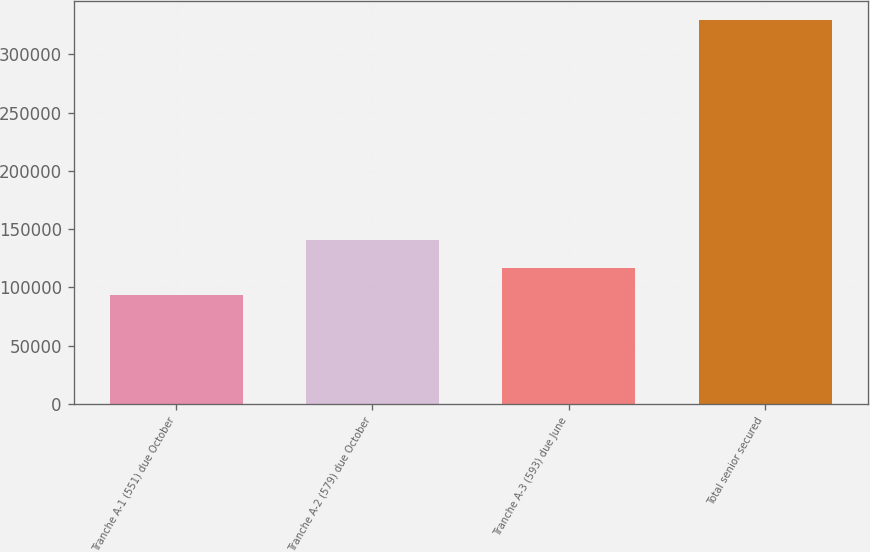Convert chart to OTSL. <chart><loc_0><loc_0><loc_500><loc_500><bar_chart><fcel>Tranche A-1 (551) due October<fcel>Tranche A-2 (579) due October<fcel>Tranche A-3 (593) due June<fcel>Total senior secured<nl><fcel>93500<fcel>140700<fcel>117100<fcel>329500<nl></chart> 